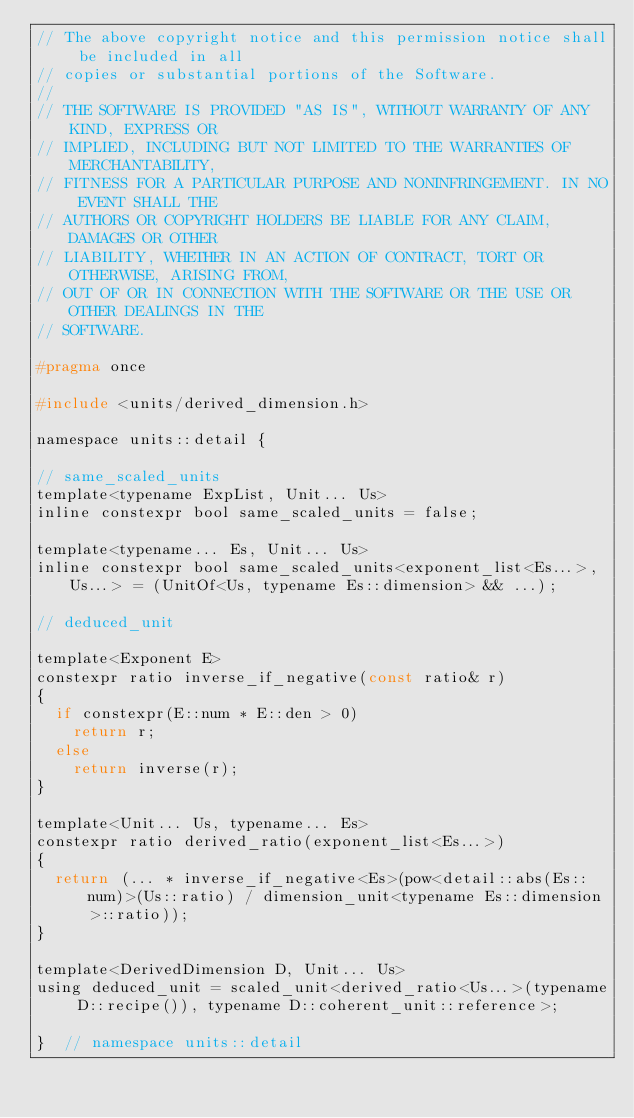<code> <loc_0><loc_0><loc_500><loc_500><_C_>// The above copyright notice and this permission notice shall be included in all
// copies or substantial portions of the Software.
//
// THE SOFTWARE IS PROVIDED "AS IS", WITHOUT WARRANTY OF ANY KIND, EXPRESS OR
// IMPLIED, INCLUDING BUT NOT LIMITED TO THE WARRANTIES OF MERCHANTABILITY,
// FITNESS FOR A PARTICULAR PURPOSE AND NONINFRINGEMENT. IN NO EVENT SHALL THE
// AUTHORS OR COPYRIGHT HOLDERS BE LIABLE FOR ANY CLAIM, DAMAGES OR OTHER
// LIABILITY, WHETHER IN AN ACTION OF CONTRACT, TORT OR OTHERWISE, ARISING FROM,
// OUT OF OR IN CONNECTION WITH THE SOFTWARE OR THE USE OR OTHER DEALINGS IN THE
// SOFTWARE.

#pragma once

#include <units/derived_dimension.h>

namespace units::detail {

// same_scaled_units
template<typename ExpList, Unit... Us>
inline constexpr bool same_scaled_units = false;

template<typename... Es, Unit... Us>
inline constexpr bool same_scaled_units<exponent_list<Es...>, Us...> = (UnitOf<Us, typename Es::dimension> && ...);

// deduced_unit

template<Exponent E>
constexpr ratio inverse_if_negative(const ratio& r)
{
  if constexpr(E::num * E::den > 0)
    return r;
  else
    return inverse(r);
}

template<Unit... Us, typename... Es>
constexpr ratio derived_ratio(exponent_list<Es...>)
{
  return (... * inverse_if_negative<Es>(pow<detail::abs(Es::num)>(Us::ratio) / dimension_unit<typename Es::dimension>::ratio));
}

template<DerivedDimension D, Unit... Us>
using deduced_unit = scaled_unit<derived_ratio<Us...>(typename D::recipe()), typename D::coherent_unit::reference>;

}  // namespace units::detail
</code> 